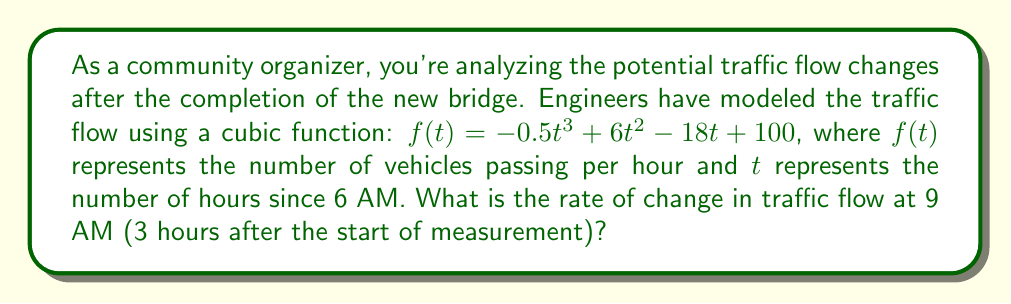What is the answer to this math problem? To find the rate of change in traffic flow at 9 AM, we need to calculate the derivative of the given function and evaluate it at $t = 3$ hours.

1. Given function: $f(t) = -0.5t^3 + 6t^2 - 18t + 100$

2. Calculate the derivative $f'(t)$:
   $f'(t) = -1.5t^2 + 12t - 18$

3. Evaluate $f'(t)$ at $t = 3$:
   $f'(3) = -1.5(3)^2 + 12(3) - 18$
   $= -1.5(9) + 36 - 18$
   $= -13.5 + 36 - 18$
   $= 4.5$

The rate of change is positive, indicating an increasing traffic flow at 9 AM. This information is crucial for community organizers to understand peak hours and potential congestion issues after the bridge completion.
Answer: The rate of change in traffic flow at 9 AM is 4.5 vehicles per hour per hour. 